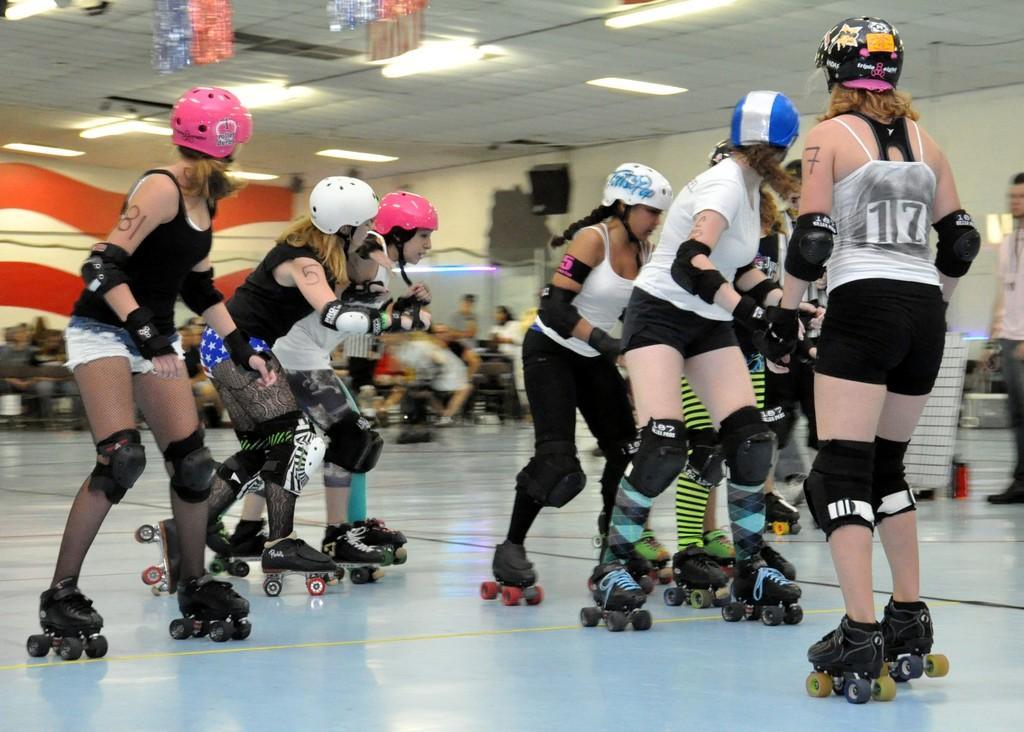Please provide a concise description of this image. In this image there are group of people with helmets are doing skating with the skating shoes, and in the background there are group of people, lights. 